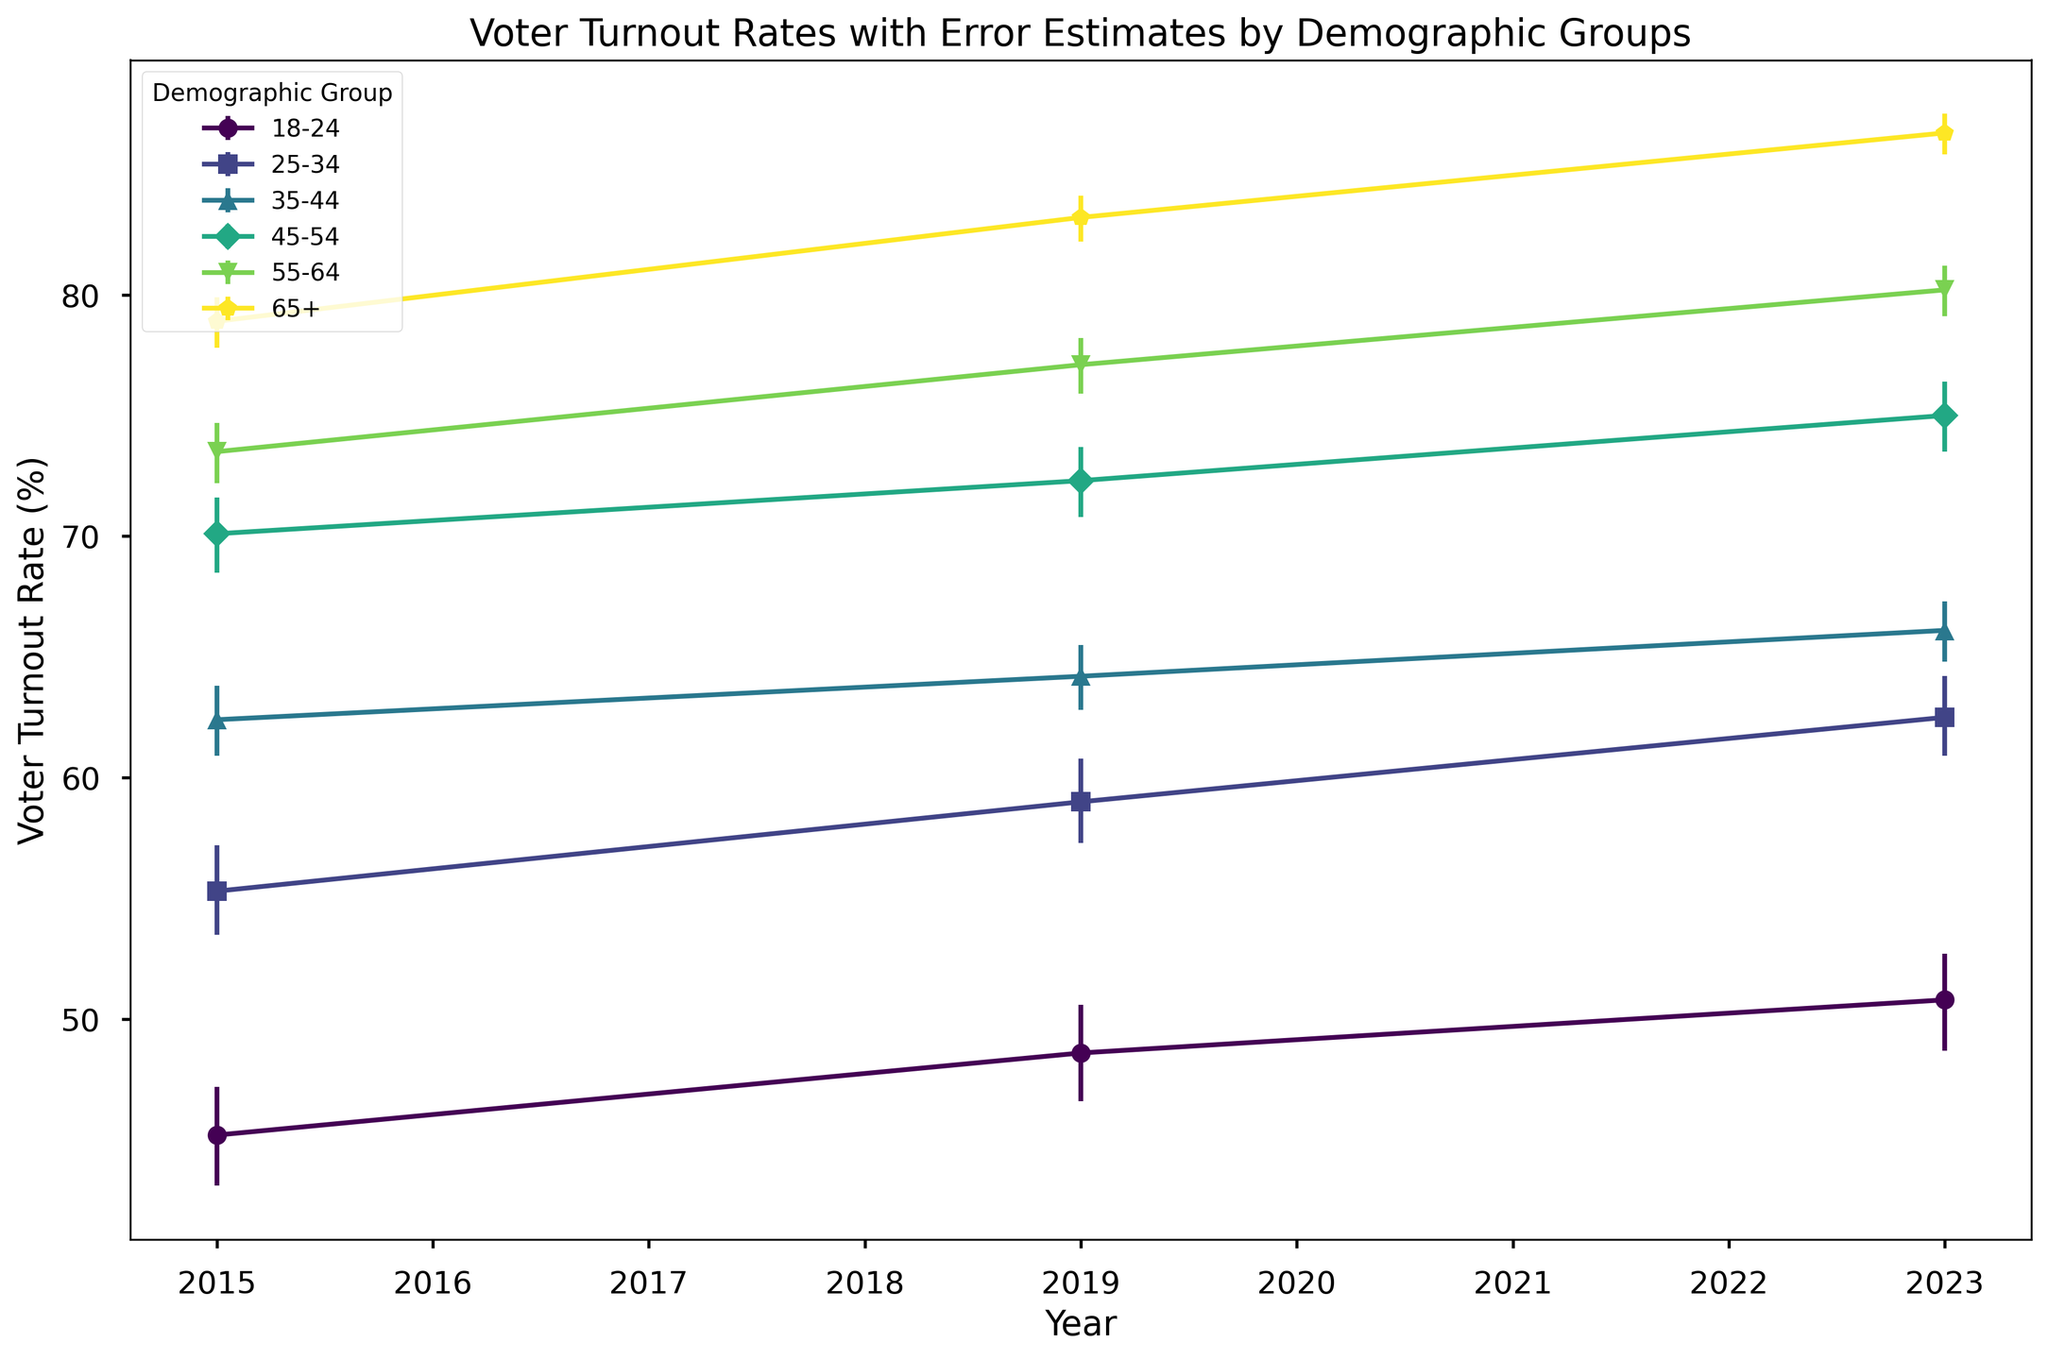What is the voter turnout rate for the 18-24 demographic in 2023? Look at the plot and identify the turnout rate for the 18-24 demographic in the year 2023.
Answer: 50.8% Which demographic group had the highest voter turnout rate in 2015? Identify the demographic group with the tallest marker for the year 2015.
Answer: 65+ By how much did the voter turnout rate for the 25-34 demographic group change from 2015 to 2023? Calculate the difference between the turnout rates for 2023 and 2015 for the 25-34 demographic. For 2015, it is 55.3%, and for 2023, it is 62.5%. The change is 62.5% - 55.3%.
Answer: 7.2% Which demographic group showed the smallest increase in voter turnout rate between 2019 and 2023? Calculate the increase for each demographic group from 2019 to 2023. The smallest increase is identified by comparing all calculated values. For example, the 18-24 group increased from 48.6% to 50.8%, a 2.2% increase, which is the smallest increase observed.
Answer: 18-24 What is the average voter turnout rate of the 45-54 demographic group over the years 2015, 2019, and 2023? Sum the turnout rates for the 45-54 group over three years (70.1% + 72.3% + 75.0%) and divide by 3. (70.1 + 72.3 + 75.0) / 3 = 72.47%.
Answer: 72.47% Which demographic experienced the largest change in their error estimate from 2015 to 2023? Compare the differences in error estimates (average of upper and lower errors) for all demographics from 2015 to 2023. The 18-24 group had a change from an average error of (2.1+2.0)/2=2.05 in 2015 to (2.1+1.9)/2=2.0 in 2023, a decrease of 0.05, whereas the 65+ group had a change from (1.1+1.0)/2=1.05 to (0.9+0.8)/2=0.85, a decrease of 0.2, which is the largest change.
Answer: 65+ By how much did the voter turnout rate change for the 65+ demographic group from 2015 to 2019? Calculate the difference in turnout rates for the 65+ group between 2015 and 2019. For 2015, it is 78.9%, and for 2019, it is 83.2%. The change is 83.2% - 78.9%.
Answer: 4.3% Which two demographic groups had the most similar voter turnout rates in 2023? Compare the turnout rates for all demographic groups in 2023 and find the two groups with the smallest difference, which are 35-44 at 66.1% and 25-34 at 62.5%, with a difference of 3.6%.
Answer: 25-34 and 35-44 What is the combined error estimate range for the 55-64 demographic group in 2023? Add the lower and upper error estimates for the 55-64 group in 2023. The lower error is 1.1%, and the upper error is 1.0%. Combined, it is 1.1% + 1.0% = 2.1%.
Answer: 2.1% Looking at the trend, which demographic group's voter turnout rate is increasing the fastest from 2015 to 2023? Observe the slopes of the lines for each demographic group from 2015 to 2023. The steepest line indicates the fastest increase. The 65+ group has the steepest increase from 78.9% in 2015 to 86.7% in 2023.
Answer: 65+ 